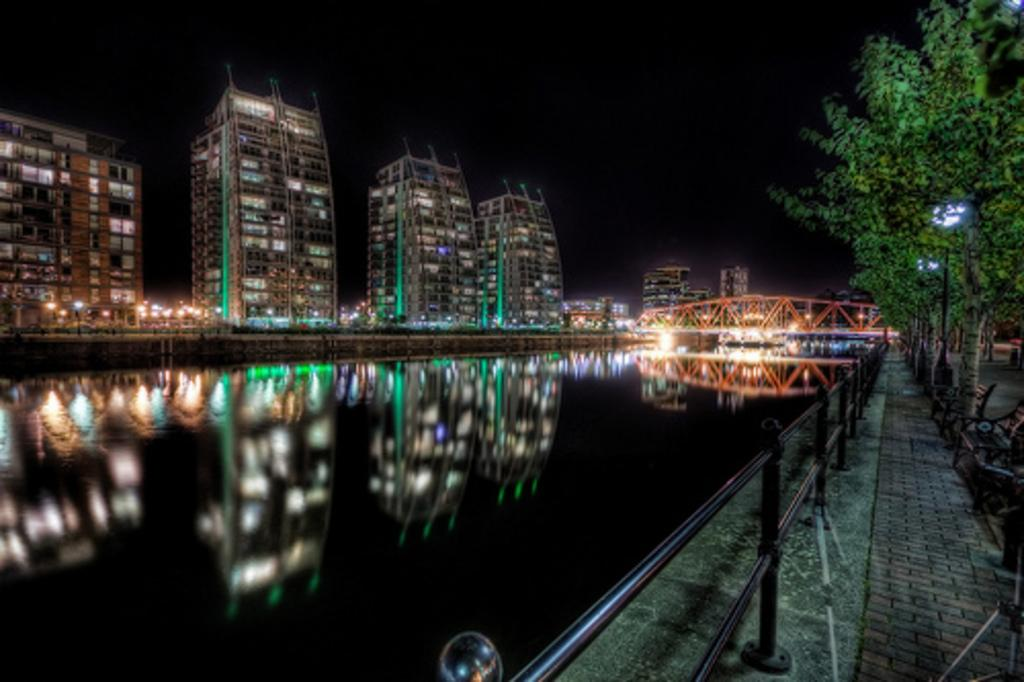What body of water is present in the image? There is a lake in the image. How is the lake crossed in the image? There is a bridge built over the lake. What can be seen to the left of the lake? There are buildings to the left of the lake. What can be seen to the right of the lake? There are trees and benches to the right of the lake. What type of lighting is present in the image? There are street lights in the image. Reasoning: Let's think step by step by step in order to produce the conversation. We start by identifying the main subject in the image, which is the lake. Then, we expand the conversation to include other elements that are also visible, such as the bridge, buildings, trees, benches, and street lights. Each question is designed to elicit a specific detail about the image that is known from the provided facts. Absurd Question/Answer: What type of shoes are being worn by the lake in the image? The lake does not wear shoes; it is a body of water. 